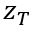Convert formula to latex. <formula><loc_0><loc_0><loc_500><loc_500>z _ { T }</formula> 